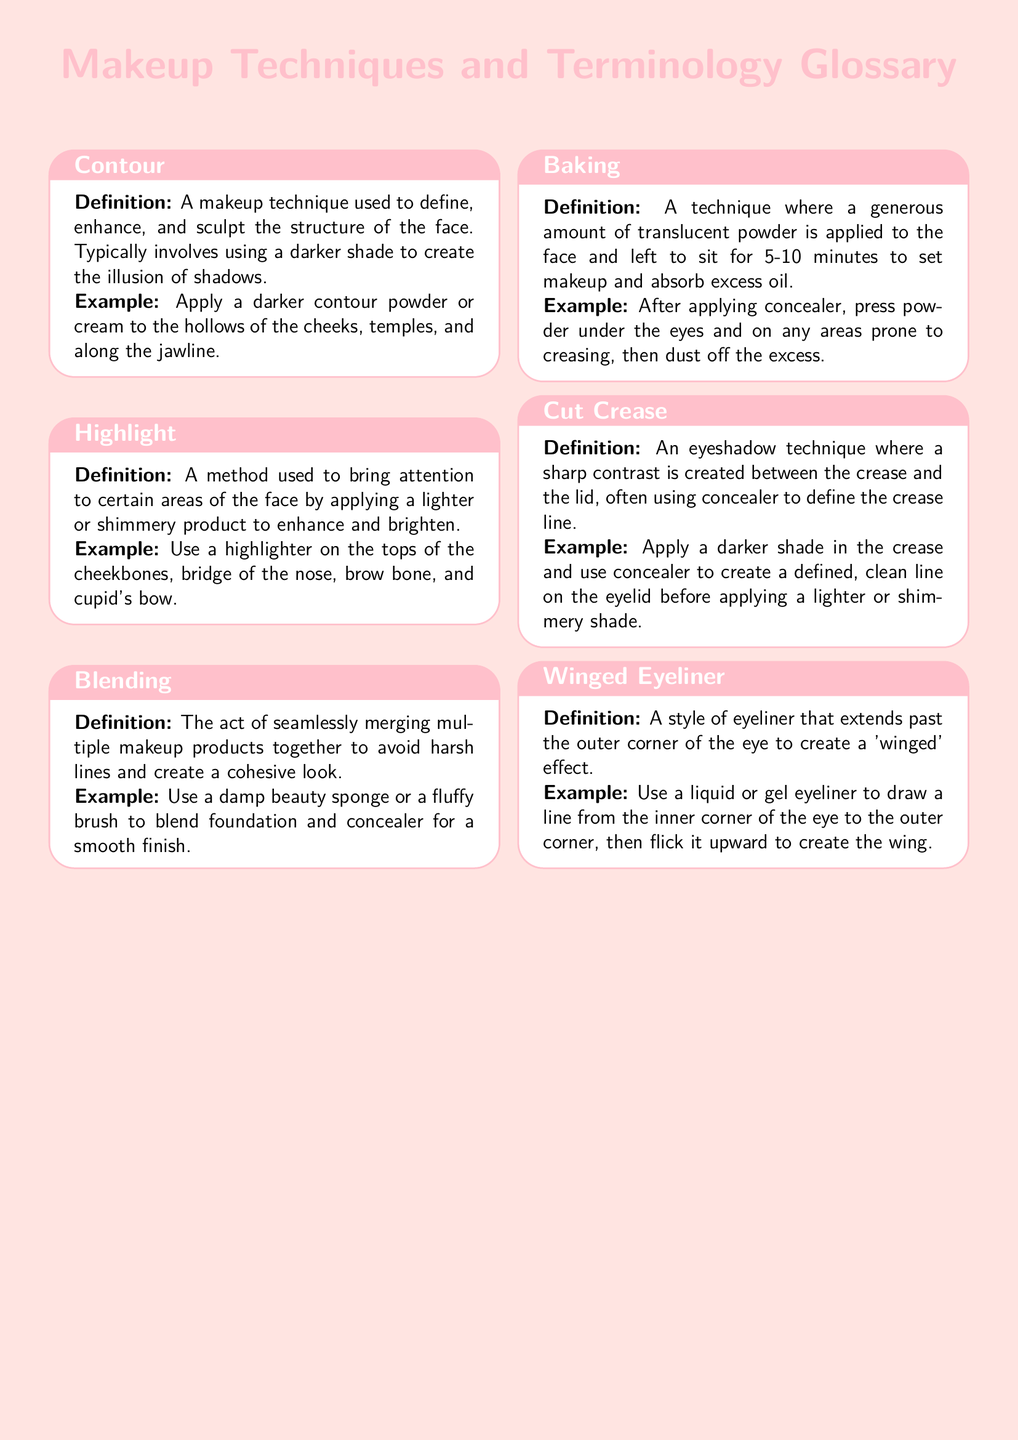What is the title of the document? The title is prominently displayed at the top of the document in a large font and is "Makeup Techniques and Terminology Glossary."
Answer: Makeup Techniques and Terminology Glossary How many makeup techniques are defined in the document? The document lists a total of six techniques and terms related to makeup.
Answer: 6 What technique involves using a darker shade to create the illusion of shadows? The term that describes this technique is defined in the glossary.
Answer: Contour What is the purpose of blending in makeup? The definition explicitly states that blending is used to merge multiple products together to avoid harsh lines.
Answer: Seamlessly merging products Which makeup technique applies translucent powder for setting makeup? The document defines this technique as "Baking."
Answer: Baking What area of the face is highlighted according to the example for highlight? The document mentions several areas where highlighter is applied; one of them is specified in the example.
Answer: Cheekbones What is the visual description of winged eyeliner provided in the document? The explanation states that winged eyeliner extends past the outer corner of the eye.
Answer: Extends past outer corner Which tool is suggested for blending foundation and concealer? A specific makeup tool is recommended in the definition for blending.
Answer: Damp beauty sponge or fluffy brush 